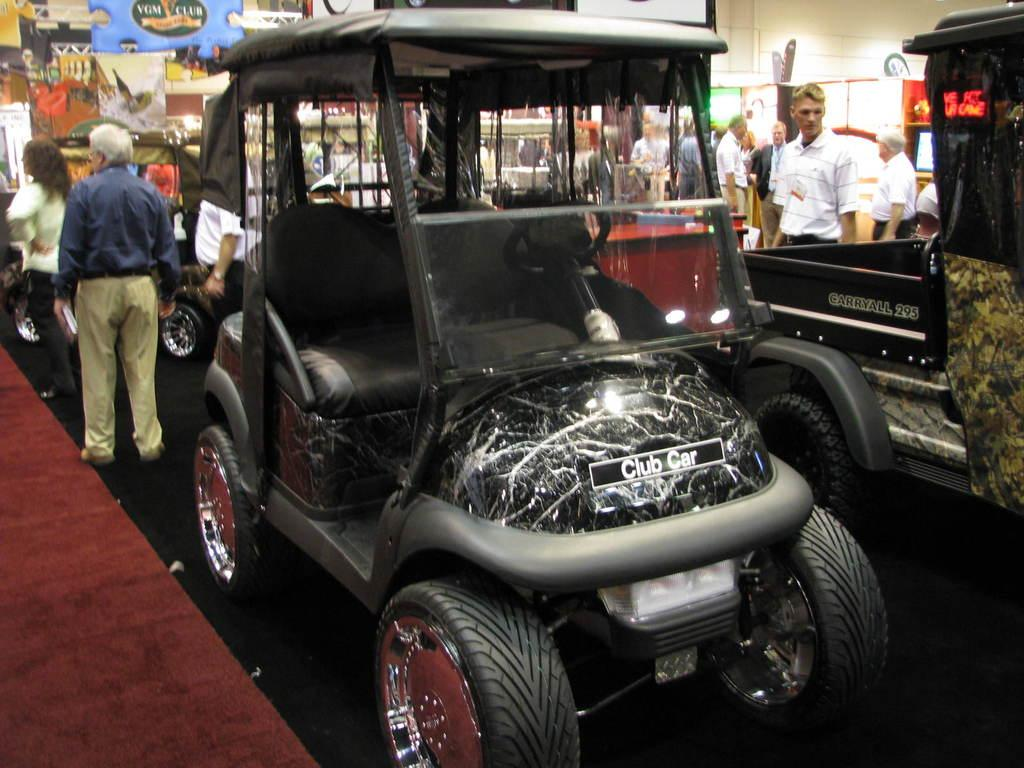What types of objects can be seen in the image? There are vehicles and people in the image. Can you describe the vehicles in the image? Unfortunately, the facts provided do not give specific details about the vehicles. What can be seen in the background of the image? There are objects visible in the background of the image, but the facts do not specify what these objects are. We start by identifying the main subjects in the image, which are vehicles and people. Then, we attempt to describe the vehicles and background objects, but we cannot provide specific details due to the lack of information in the facts. How many rabbits can be seen hopping around in the image? There are no rabbits present in the image. What is the comparison between the respect shown by the people in the image and the respect shown by the vehicles? The facts provided do not mention anything about respect, so it is impossible to make a comparison between the people and vehicles in this regard. 